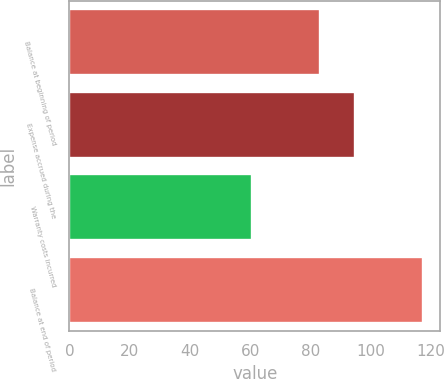Convert chart to OTSL. <chart><loc_0><loc_0><loc_500><loc_500><bar_chart><fcel>Balance at beginning of period<fcel>Expense accrued during the<fcel>Warranty costs incurred<fcel>Balance at end of period<nl><fcel>83.1<fcel>94.8<fcel>60.7<fcel>117.2<nl></chart> 